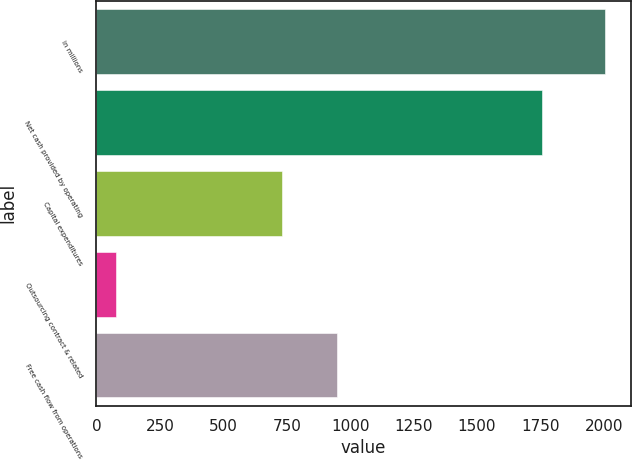<chart> <loc_0><loc_0><loc_500><loc_500><bar_chart><fcel>in millions<fcel>Net cash provided by operating<fcel>Capital expenditures<fcel>Outsourcing contract & related<fcel>Free cash flow from operations<nl><fcel>2006<fcel>1756<fcel>732<fcel>77<fcel>947<nl></chart> 